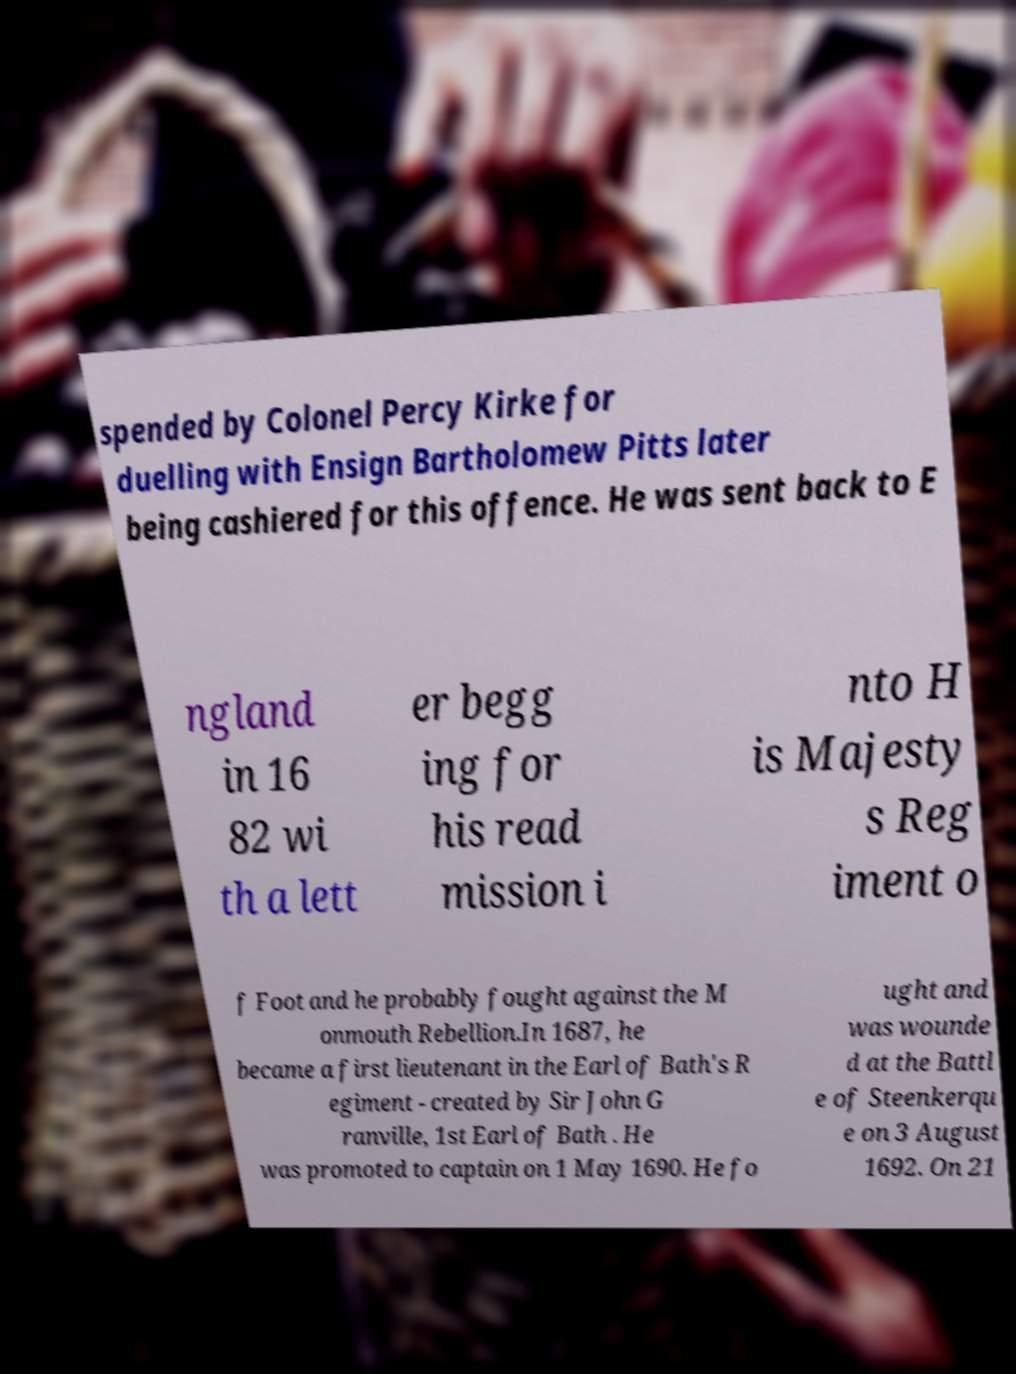I need the written content from this picture converted into text. Can you do that? spended by Colonel Percy Kirke for duelling with Ensign Bartholomew Pitts later being cashiered for this offence. He was sent back to E ngland in 16 82 wi th a lett er begg ing for his read mission i nto H is Majesty s Reg iment o f Foot and he probably fought against the M onmouth Rebellion.In 1687, he became a first lieutenant in the Earl of Bath's R egiment - created by Sir John G ranville, 1st Earl of Bath . He was promoted to captain on 1 May 1690. He fo ught and was wounde d at the Battl e of Steenkerqu e on 3 August 1692. On 21 